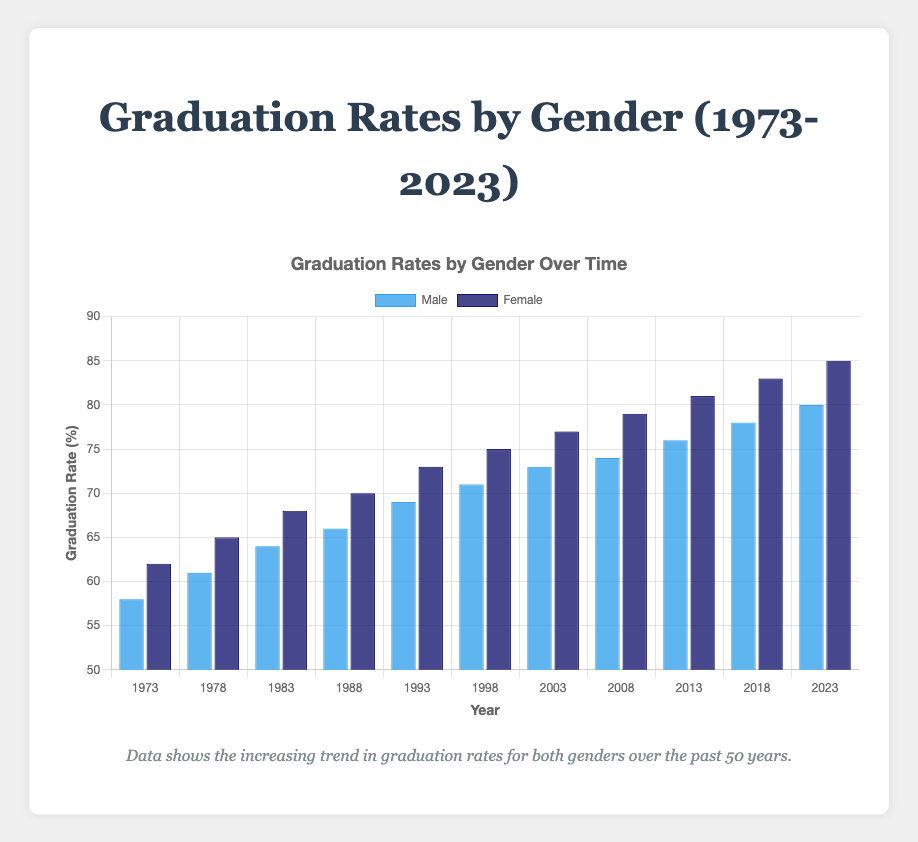What is the highest graduation rate for females in the data? The data shows graduation rates over various years, the highest female graduation rate is in 2023 at 85%.
Answer: 85% By how much did the male graduation rate increase from 1973 to 2023? The male graduation rate in 1973 is 58%, and in 2023 it is 80%. The difference is calculated by 80% - 58% = 22%.
Answer: 22% Which year saw the highest graduation rate for both males and females? The highest graduation rates for both genders occur in 2023 with males at 80% and females at 85%.
Answer: 2023 Which gender had a higher graduation rate in 1988, and by how much? The female graduation rate in 1988 is 70%, and the male rate is 66%. The difference is 70% - 66% = 4%. Females had a higher graduation rate by 4%.
Answer: Females, 4% What is the average graduation rate for males over the 50 years? To find the average, sum the male graduation rates from 1973 to 2023 and divide by the number of data points. Sum is 58 + 61 + 64 + 66 + 69 + 71 + 73 + 74 + 76 + 78 + 80 = 770. Average is 770/11 = 70%.
Answer: 70% In which year did males and females both reach a graduation rate of at least 70%? The bar chart shows both genders reaching at least 70% graduation rate first in 1988 for females and then in 1998 for males. Thus, by 1998, both genders have rates above 70%.
Answer: 1998 How does the male graduation rate in 2008 compare to the female graduation rate in the same year? In 2008, the male graduation rate is 74% and the female rate is 79%. The female rate is 5% higher than the male rate.
Answer: The female rate is higher by 5% What is the total increase in graduation rate for females from 1973 to 2018? The female graduation rate in 1973 is 62%, and in 2018 it is 83%. The total increase over this period is 83% - 62% = 21%.
Answer: 21% What is the median graduation rate for males? Arrange the male graduation rates in ascending order: 58, 61, 64, 66, 69, 71, 73, 74, 76, 78, 80. The median value is the 6th data point, which is 71%.
Answer: 71% In which decade did females see the highest increase in graduation rates? Calculate the increases by decade:
  - 1973-1983: 68% - 62% = 6%
  - 1983-1993: 73% - 68% = 5%
  - 1993-2003: 77% - 73% = 4%
  - 2003-2013: 81% - 77% = 4%
  - 2013-2023: 85% - 81% = 4%
The highest increase occurred between 1973 and 1983 (6%).
Answer: 1973-1983 